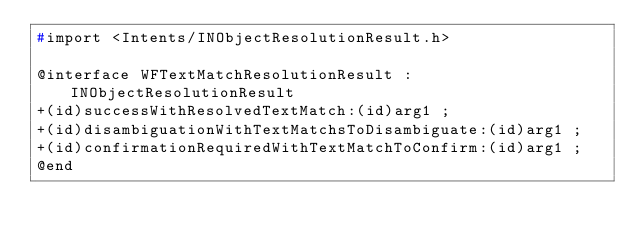<code> <loc_0><loc_0><loc_500><loc_500><_C_>#import <Intents/INObjectResolutionResult.h>

@interface WFTextMatchResolutionResult : INObjectResolutionResult
+(id)successWithResolvedTextMatch:(id)arg1 ;
+(id)disambiguationWithTextMatchsToDisambiguate:(id)arg1 ;
+(id)confirmationRequiredWithTextMatchToConfirm:(id)arg1 ;
@end

</code> 